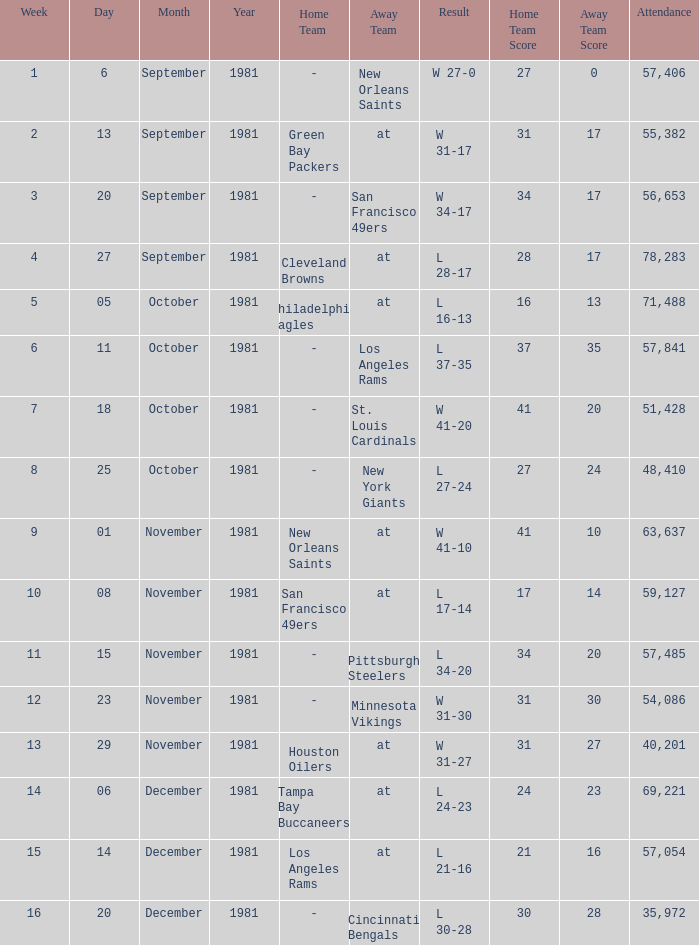What was the average number of attendance for the game on November 29, 1981 played after week 13? None. 